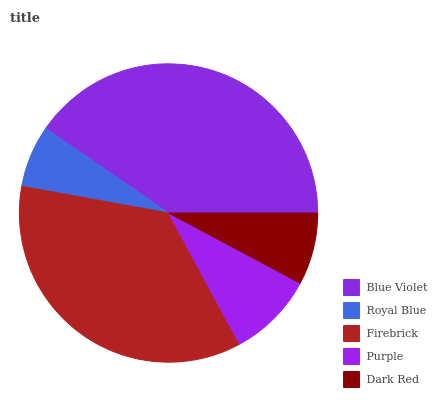Is Royal Blue the minimum?
Answer yes or no. Yes. Is Blue Violet the maximum?
Answer yes or no. Yes. Is Firebrick the minimum?
Answer yes or no. No. Is Firebrick the maximum?
Answer yes or no. No. Is Firebrick greater than Royal Blue?
Answer yes or no. Yes. Is Royal Blue less than Firebrick?
Answer yes or no. Yes. Is Royal Blue greater than Firebrick?
Answer yes or no. No. Is Firebrick less than Royal Blue?
Answer yes or no. No. Is Purple the high median?
Answer yes or no. Yes. Is Purple the low median?
Answer yes or no. Yes. Is Royal Blue the high median?
Answer yes or no. No. Is Royal Blue the low median?
Answer yes or no. No. 